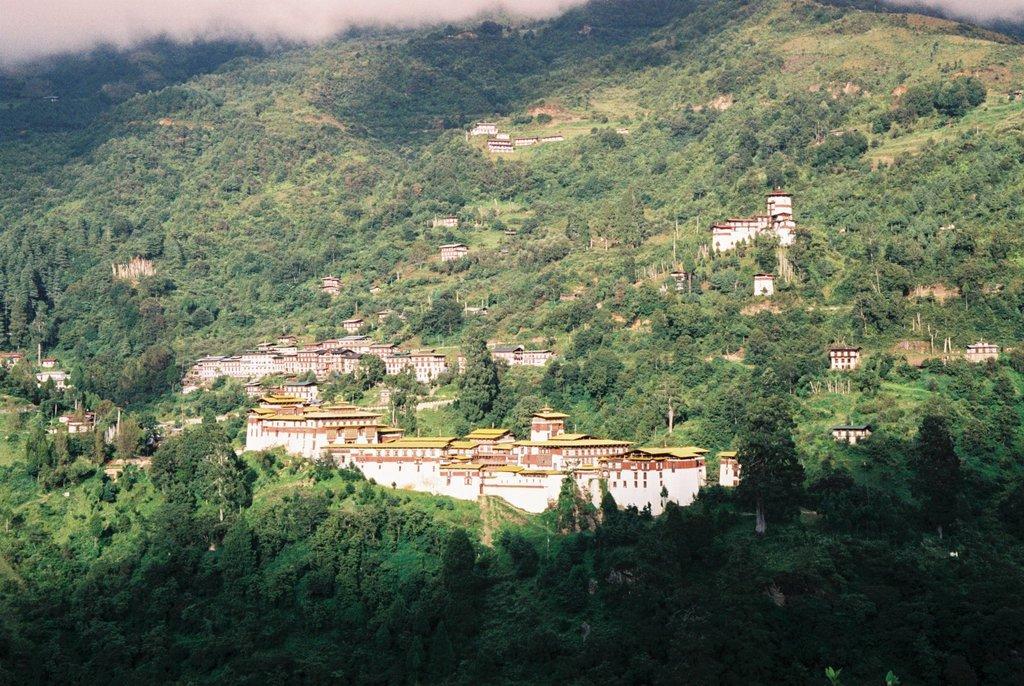Describe this image in one or two sentences. In this image we can see the buildings on the hill. We can also see the trees and also the fog. 